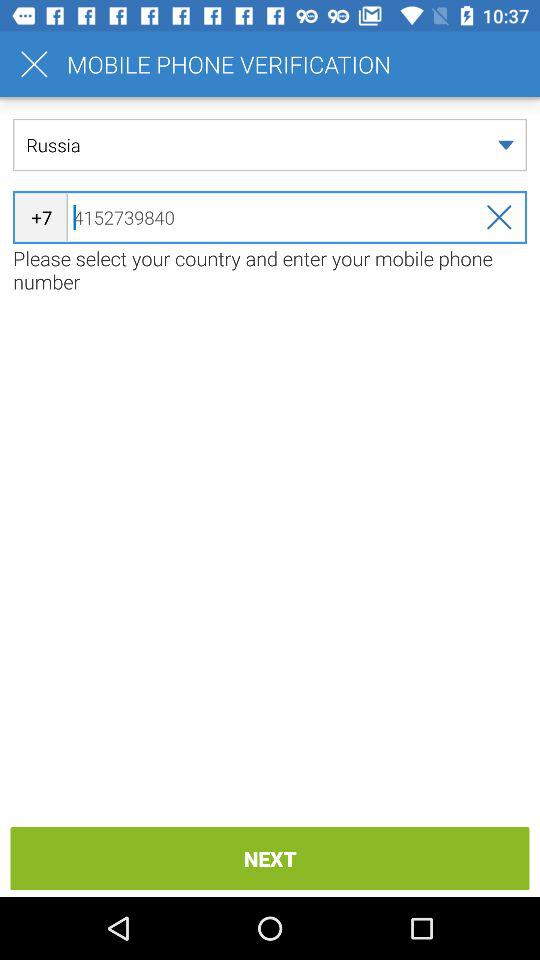What is the country code for Russia? The country code for Russia is +7. 